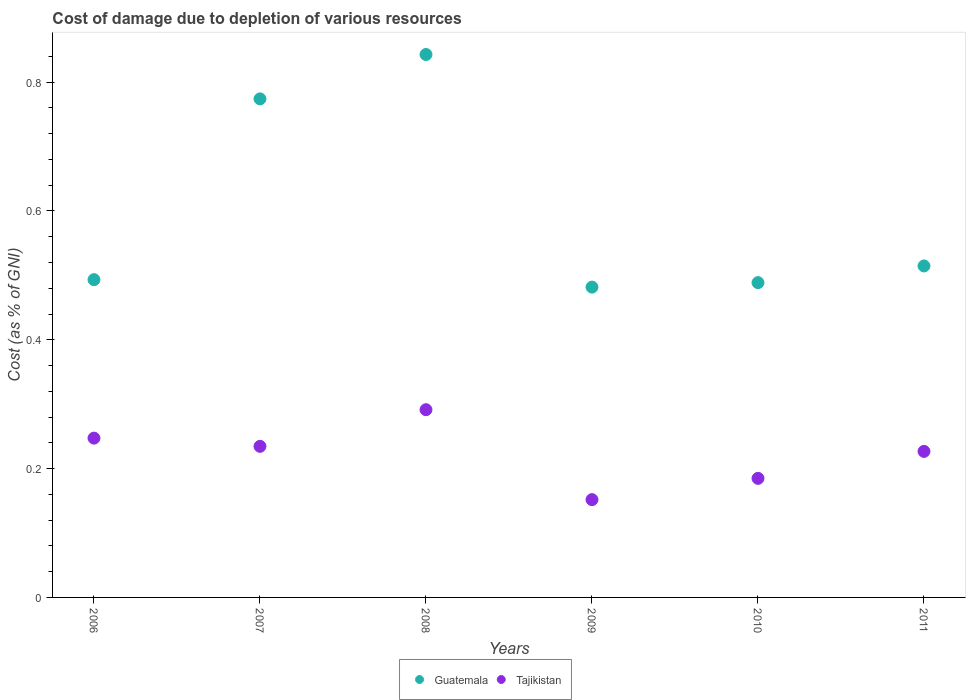How many different coloured dotlines are there?
Offer a very short reply. 2. What is the cost of damage caused due to the depletion of various resources in Tajikistan in 2007?
Provide a short and direct response. 0.23. Across all years, what is the maximum cost of damage caused due to the depletion of various resources in Guatemala?
Your answer should be compact. 0.84. Across all years, what is the minimum cost of damage caused due to the depletion of various resources in Guatemala?
Give a very brief answer. 0.48. In which year was the cost of damage caused due to the depletion of various resources in Tajikistan minimum?
Offer a very short reply. 2009. What is the total cost of damage caused due to the depletion of various resources in Tajikistan in the graph?
Give a very brief answer. 1.34. What is the difference between the cost of damage caused due to the depletion of various resources in Guatemala in 2006 and that in 2011?
Your answer should be compact. -0.02. What is the difference between the cost of damage caused due to the depletion of various resources in Tajikistan in 2006 and the cost of damage caused due to the depletion of various resources in Guatemala in 2009?
Ensure brevity in your answer.  -0.23. What is the average cost of damage caused due to the depletion of various resources in Tajikistan per year?
Your response must be concise. 0.22. In the year 2009, what is the difference between the cost of damage caused due to the depletion of various resources in Tajikistan and cost of damage caused due to the depletion of various resources in Guatemala?
Give a very brief answer. -0.33. In how many years, is the cost of damage caused due to the depletion of various resources in Tajikistan greater than 0.36 %?
Your answer should be very brief. 0. What is the ratio of the cost of damage caused due to the depletion of various resources in Tajikistan in 2007 to that in 2010?
Offer a very short reply. 1.27. Is the cost of damage caused due to the depletion of various resources in Guatemala in 2010 less than that in 2011?
Ensure brevity in your answer.  Yes. Is the difference between the cost of damage caused due to the depletion of various resources in Tajikistan in 2008 and 2011 greater than the difference between the cost of damage caused due to the depletion of various resources in Guatemala in 2008 and 2011?
Your answer should be compact. No. What is the difference between the highest and the second highest cost of damage caused due to the depletion of various resources in Tajikistan?
Make the answer very short. 0.04. What is the difference between the highest and the lowest cost of damage caused due to the depletion of various resources in Tajikistan?
Keep it short and to the point. 0.14. Is the sum of the cost of damage caused due to the depletion of various resources in Guatemala in 2006 and 2009 greater than the maximum cost of damage caused due to the depletion of various resources in Tajikistan across all years?
Give a very brief answer. Yes. Is the cost of damage caused due to the depletion of various resources in Guatemala strictly greater than the cost of damage caused due to the depletion of various resources in Tajikistan over the years?
Offer a terse response. Yes. How many years are there in the graph?
Your answer should be very brief. 6. What is the difference between two consecutive major ticks on the Y-axis?
Your answer should be very brief. 0.2. Does the graph contain any zero values?
Ensure brevity in your answer.  No. Where does the legend appear in the graph?
Provide a succinct answer. Bottom center. How many legend labels are there?
Provide a short and direct response. 2. How are the legend labels stacked?
Ensure brevity in your answer.  Horizontal. What is the title of the graph?
Keep it short and to the point. Cost of damage due to depletion of various resources. Does "Uganda" appear as one of the legend labels in the graph?
Offer a very short reply. No. What is the label or title of the Y-axis?
Your answer should be compact. Cost (as % of GNI). What is the Cost (as % of GNI) in Guatemala in 2006?
Provide a short and direct response. 0.49. What is the Cost (as % of GNI) in Tajikistan in 2006?
Offer a very short reply. 0.25. What is the Cost (as % of GNI) of Guatemala in 2007?
Offer a terse response. 0.77. What is the Cost (as % of GNI) of Tajikistan in 2007?
Your answer should be compact. 0.23. What is the Cost (as % of GNI) in Guatemala in 2008?
Your answer should be very brief. 0.84. What is the Cost (as % of GNI) in Tajikistan in 2008?
Make the answer very short. 0.29. What is the Cost (as % of GNI) in Guatemala in 2009?
Keep it short and to the point. 0.48. What is the Cost (as % of GNI) of Tajikistan in 2009?
Provide a short and direct response. 0.15. What is the Cost (as % of GNI) in Guatemala in 2010?
Give a very brief answer. 0.49. What is the Cost (as % of GNI) of Tajikistan in 2010?
Give a very brief answer. 0.18. What is the Cost (as % of GNI) in Guatemala in 2011?
Ensure brevity in your answer.  0.51. What is the Cost (as % of GNI) of Tajikistan in 2011?
Make the answer very short. 0.23. Across all years, what is the maximum Cost (as % of GNI) of Guatemala?
Keep it short and to the point. 0.84. Across all years, what is the maximum Cost (as % of GNI) in Tajikistan?
Offer a very short reply. 0.29. Across all years, what is the minimum Cost (as % of GNI) of Guatemala?
Provide a succinct answer. 0.48. Across all years, what is the minimum Cost (as % of GNI) of Tajikistan?
Your response must be concise. 0.15. What is the total Cost (as % of GNI) of Guatemala in the graph?
Offer a very short reply. 3.6. What is the total Cost (as % of GNI) of Tajikistan in the graph?
Provide a short and direct response. 1.34. What is the difference between the Cost (as % of GNI) in Guatemala in 2006 and that in 2007?
Keep it short and to the point. -0.28. What is the difference between the Cost (as % of GNI) of Tajikistan in 2006 and that in 2007?
Make the answer very short. 0.01. What is the difference between the Cost (as % of GNI) in Guatemala in 2006 and that in 2008?
Your response must be concise. -0.35. What is the difference between the Cost (as % of GNI) in Tajikistan in 2006 and that in 2008?
Your answer should be very brief. -0.04. What is the difference between the Cost (as % of GNI) of Guatemala in 2006 and that in 2009?
Offer a terse response. 0.01. What is the difference between the Cost (as % of GNI) of Tajikistan in 2006 and that in 2009?
Your answer should be compact. 0.1. What is the difference between the Cost (as % of GNI) of Guatemala in 2006 and that in 2010?
Provide a short and direct response. 0. What is the difference between the Cost (as % of GNI) of Tajikistan in 2006 and that in 2010?
Ensure brevity in your answer.  0.06. What is the difference between the Cost (as % of GNI) in Guatemala in 2006 and that in 2011?
Make the answer very short. -0.02. What is the difference between the Cost (as % of GNI) of Tajikistan in 2006 and that in 2011?
Provide a succinct answer. 0.02. What is the difference between the Cost (as % of GNI) in Guatemala in 2007 and that in 2008?
Provide a succinct answer. -0.07. What is the difference between the Cost (as % of GNI) in Tajikistan in 2007 and that in 2008?
Offer a terse response. -0.06. What is the difference between the Cost (as % of GNI) in Guatemala in 2007 and that in 2009?
Give a very brief answer. 0.29. What is the difference between the Cost (as % of GNI) of Tajikistan in 2007 and that in 2009?
Your response must be concise. 0.08. What is the difference between the Cost (as % of GNI) of Guatemala in 2007 and that in 2010?
Your response must be concise. 0.29. What is the difference between the Cost (as % of GNI) of Tajikistan in 2007 and that in 2010?
Your answer should be very brief. 0.05. What is the difference between the Cost (as % of GNI) in Guatemala in 2007 and that in 2011?
Provide a succinct answer. 0.26. What is the difference between the Cost (as % of GNI) of Tajikistan in 2007 and that in 2011?
Provide a succinct answer. 0.01. What is the difference between the Cost (as % of GNI) in Guatemala in 2008 and that in 2009?
Keep it short and to the point. 0.36. What is the difference between the Cost (as % of GNI) in Tajikistan in 2008 and that in 2009?
Your answer should be very brief. 0.14. What is the difference between the Cost (as % of GNI) in Guatemala in 2008 and that in 2010?
Ensure brevity in your answer.  0.35. What is the difference between the Cost (as % of GNI) of Tajikistan in 2008 and that in 2010?
Your answer should be compact. 0.11. What is the difference between the Cost (as % of GNI) in Guatemala in 2008 and that in 2011?
Keep it short and to the point. 0.33. What is the difference between the Cost (as % of GNI) of Tajikistan in 2008 and that in 2011?
Give a very brief answer. 0.06. What is the difference between the Cost (as % of GNI) in Guatemala in 2009 and that in 2010?
Offer a terse response. -0.01. What is the difference between the Cost (as % of GNI) in Tajikistan in 2009 and that in 2010?
Your response must be concise. -0.03. What is the difference between the Cost (as % of GNI) in Guatemala in 2009 and that in 2011?
Keep it short and to the point. -0.03. What is the difference between the Cost (as % of GNI) in Tajikistan in 2009 and that in 2011?
Provide a succinct answer. -0.07. What is the difference between the Cost (as % of GNI) in Guatemala in 2010 and that in 2011?
Offer a very short reply. -0.03. What is the difference between the Cost (as % of GNI) in Tajikistan in 2010 and that in 2011?
Provide a short and direct response. -0.04. What is the difference between the Cost (as % of GNI) of Guatemala in 2006 and the Cost (as % of GNI) of Tajikistan in 2007?
Make the answer very short. 0.26. What is the difference between the Cost (as % of GNI) in Guatemala in 2006 and the Cost (as % of GNI) in Tajikistan in 2008?
Provide a succinct answer. 0.2. What is the difference between the Cost (as % of GNI) of Guatemala in 2006 and the Cost (as % of GNI) of Tajikistan in 2009?
Your response must be concise. 0.34. What is the difference between the Cost (as % of GNI) in Guatemala in 2006 and the Cost (as % of GNI) in Tajikistan in 2010?
Offer a terse response. 0.31. What is the difference between the Cost (as % of GNI) in Guatemala in 2006 and the Cost (as % of GNI) in Tajikistan in 2011?
Offer a terse response. 0.27. What is the difference between the Cost (as % of GNI) of Guatemala in 2007 and the Cost (as % of GNI) of Tajikistan in 2008?
Provide a succinct answer. 0.48. What is the difference between the Cost (as % of GNI) of Guatemala in 2007 and the Cost (as % of GNI) of Tajikistan in 2009?
Your response must be concise. 0.62. What is the difference between the Cost (as % of GNI) in Guatemala in 2007 and the Cost (as % of GNI) in Tajikistan in 2010?
Ensure brevity in your answer.  0.59. What is the difference between the Cost (as % of GNI) of Guatemala in 2007 and the Cost (as % of GNI) of Tajikistan in 2011?
Your answer should be very brief. 0.55. What is the difference between the Cost (as % of GNI) of Guatemala in 2008 and the Cost (as % of GNI) of Tajikistan in 2009?
Ensure brevity in your answer.  0.69. What is the difference between the Cost (as % of GNI) in Guatemala in 2008 and the Cost (as % of GNI) in Tajikistan in 2010?
Keep it short and to the point. 0.66. What is the difference between the Cost (as % of GNI) in Guatemala in 2008 and the Cost (as % of GNI) in Tajikistan in 2011?
Ensure brevity in your answer.  0.62. What is the difference between the Cost (as % of GNI) of Guatemala in 2009 and the Cost (as % of GNI) of Tajikistan in 2010?
Provide a short and direct response. 0.3. What is the difference between the Cost (as % of GNI) in Guatemala in 2009 and the Cost (as % of GNI) in Tajikistan in 2011?
Give a very brief answer. 0.26. What is the difference between the Cost (as % of GNI) of Guatemala in 2010 and the Cost (as % of GNI) of Tajikistan in 2011?
Provide a succinct answer. 0.26. What is the average Cost (as % of GNI) in Guatemala per year?
Your response must be concise. 0.6. What is the average Cost (as % of GNI) of Tajikistan per year?
Offer a terse response. 0.22. In the year 2006, what is the difference between the Cost (as % of GNI) in Guatemala and Cost (as % of GNI) in Tajikistan?
Make the answer very short. 0.25. In the year 2007, what is the difference between the Cost (as % of GNI) in Guatemala and Cost (as % of GNI) in Tajikistan?
Provide a succinct answer. 0.54. In the year 2008, what is the difference between the Cost (as % of GNI) of Guatemala and Cost (as % of GNI) of Tajikistan?
Your answer should be very brief. 0.55. In the year 2009, what is the difference between the Cost (as % of GNI) of Guatemala and Cost (as % of GNI) of Tajikistan?
Make the answer very short. 0.33. In the year 2010, what is the difference between the Cost (as % of GNI) of Guatemala and Cost (as % of GNI) of Tajikistan?
Your answer should be very brief. 0.3. In the year 2011, what is the difference between the Cost (as % of GNI) in Guatemala and Cost (as % of GNI) in Tajikistan?
Offer a very short reply. 0.29. What is the ratio of the Cost (as % of GNI) in Guatemala in 2006 to that in 2007?
Your answer should be compact. 0.64. What is the ratio of the Cost (as % of GNI) in Tajikistan in 2006 to that in 2007?
Ensure brevity in your answer.  1.05. What is the ratio of the Cost (as % of GNI) of Guatemala in 2006 to that in 2008?
Your response must be concise. 0.59. What is the ratio of the Cost (as % of GNI) of Tajikistan in 2006 to that in 2008?
Provide a short and direct response. 0.85. What is the ratio of the Cost (as % of GNI) of Tajikistan in 2006 to that in 2009?
Keep it short and to the point. 1.63. What is the ratio of the Cost (as % of GNI) in Guatemala in 2006 to that in 2010?
Your answer should be compact. 1.01. What is the ratio of the Cost (as % of GNI) in Tajikistan in 2006 to that in 2010?
Your answer should be compact. 1.34. What is the ratio of the Cost (as % of GNI) of Guatemala in 2006 to that in 2011?
Give a very brief answer. 0.96. What is the ratio of the Cost (as % of GNI) in Tajikistan in 2006 to that in 2011?
Your response must be concise. 1.09. What is the ratio of the Cost (as % of GNI) of Guatemala in 2007 to that in 2008?
Offer a very short reply. 0.92. What is the ratio of the Cost (as % of GNI) in Tajikistan in 2007 to that in 2008?
Offer a very short reply. 0.8. What is the ratio of the Cost (as % of GNI) of Guatemala in 2007 to that in 2009?
Your answer should be very brief. 1.61. What is the ratio of the Cost (as % of GNI) of Tajikistan in 2007 to that in 2009?
Ensure brevity in your answer.  1.55. What is the ratio of the Cost (as % of GNI) of Guatemala in 2007 to that in 2010?
Ensure brevity in your answer.  1.58. What is the ratio of the Cost (as % of GNI) of Tajikistan in 2007 to that in 2010?
Keep it short and to the point. 1.27. What is the ratio of the Cost (as % of GNI) of Guatemala in 2007 to that in 2011?
Ensure brevity in your answer.  1.5. What is the ratio of the Cost (as % of GNI) of Tajikistan in 2007 to that in 2011?
Your response must be concise. 1.03. What is the ratio of the Cost (as % of GNI) of Guatemala in 2008 to that in 2009?
Offer a very short reply. 1.75. What is the ratio of the Cost (as % of GNI) of Tajikistan in 2008 to that in 2009?
Your answer should be compact. 1.92. What is the ratio of the Cost (as % of GNI) in Guatemala in 2008 to that in 2010?
Provide a short and direct response. 1.72. What is the ratio of the Cost (as % of GNI) of Tajikistan in 2008 to that in 2010?
Your response must be concise. 1.58. What is the ratio of the Cost (as % of GNI) in Guatemala in 2008 to that in 2011?
Provide a short and direct response. 1.64. What is the ratio of the Cost (as % of GNI) of Tajikistan in 2008 to that in 2011?
Keep it short and to the point. 1.29. What is the ratio of the Cost (as % of GNI) in Guatemala in 2009 to that in 2010?
Keep it short and to the point. 0.99. What is the ratio of the Cost (as % of GNI) of Tajikistan in 2009 to that in 2010?
Offer a terse response. 0.82. What is the ratio of the Cost (as % of GNI) of Guatemala in 2009 to that in 2011?
Make the answer very short. 0.94. What is the ratio of the Cost (as % of GNI) of Tajikistan in 2009 to that in 2011?
Your answer should be compact. 0.67. What is the ratio of the Cost (as % of GNI) of Guatemala in 2010 to that in 2011?
Your answer should be compact. 0.95. What is the ratio of the Cost (as % of GNI) in Tajikistan in 2010 to that in 2011?
Your answer should be very brief. 0.82. What is the difference between the highest and the second highest Cost (as % of GNI) of Guatemala?
Your answer should be very brief. 0.07. What is the difference between the highest and the second highest Cost (as % of GNI) in Tajikistan?
Provide a succinct answer. 0.04. What is the difference between the highest and the lowest Cost (as % of GNI) in Guatemala?
Your answer should be very brief. 0.36. What is the difference between the highest and the lowest Cost (as % of GNI) in Tajikistan?
Keep it short and to the point. 0.14. 